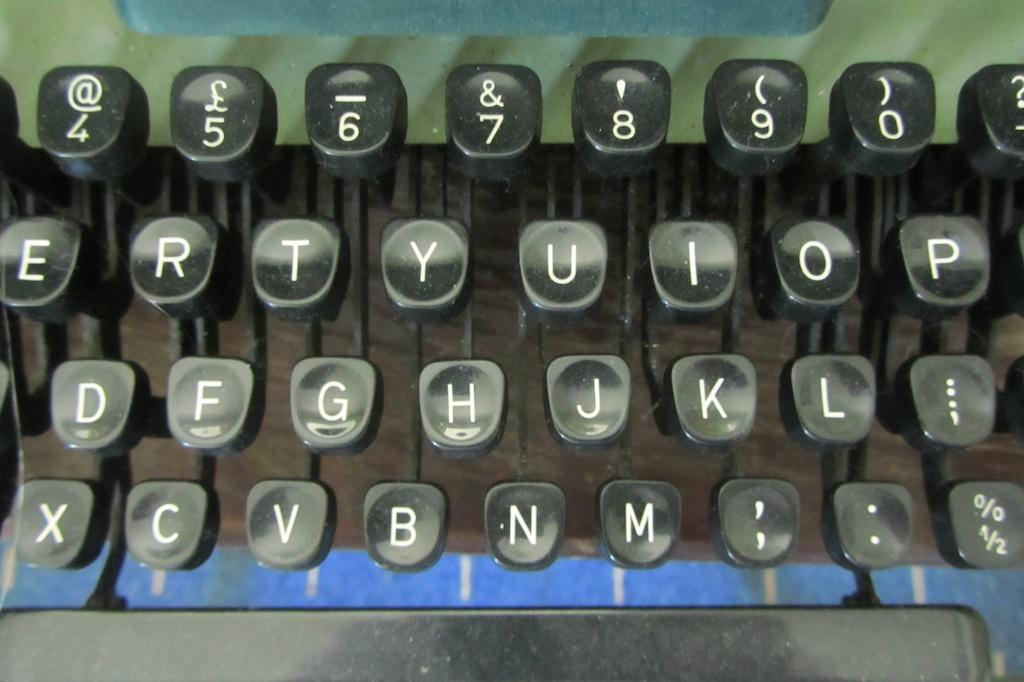<image>
Present a compact description of the photo's key features. An old manual keyboard's keys showing partial rows such as ERTYUIOP on the top. 